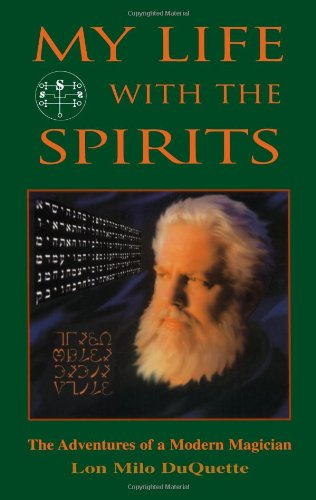What is the title of this book? The title of the book is 'My Life With The Spirits: The Adventures of a Modern Magician', chronicling the personal experiences and magical journey of Lon Milo DuQuette. 